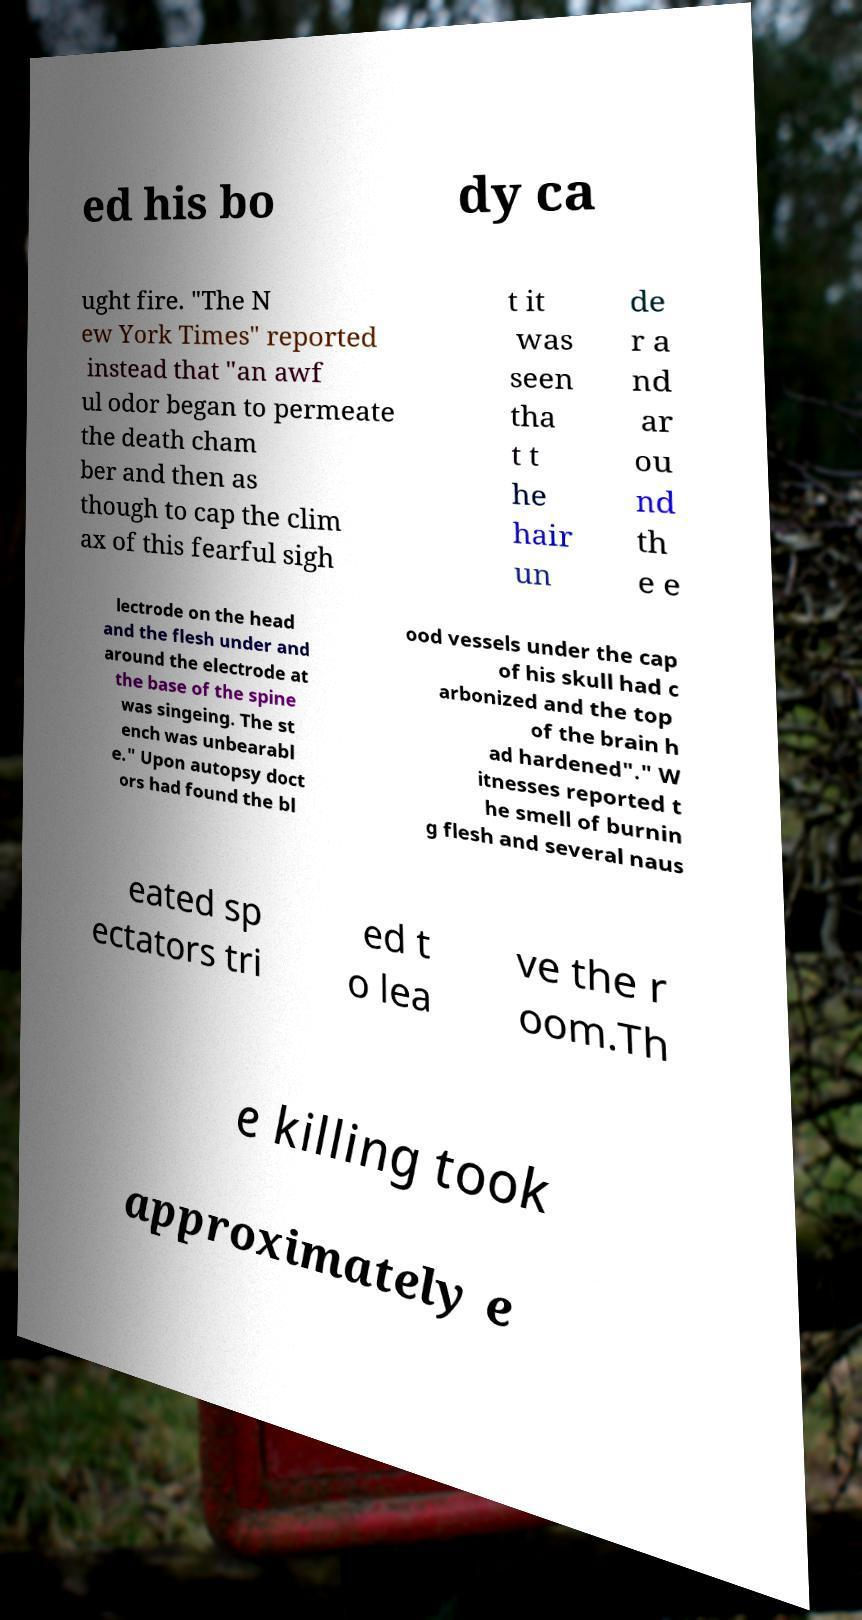For documentation purposes, I need the text within this image transcribed. Could you provide that? ed his bo dy ca ught fire. "The N ew York Times" reported instead that "an awf ul odor began to permeate the death cham ber and then as though to cap the clim ax of this fearful sigh t it was seen tha t t he hair un de r a nd ar ou nd th e e lectrode on the head and the flesh under and around the electrode at the base of the spine was singeing. The st ench was unbearabl e." Upon autopsy doct ors had found the bl ood vessels under the cap of his skull had c arbonized and the top of the brain h ad hardened"." W itnesses reported t he smell of burnin g flesh and several naus eated sp ectators tri ed t o lea ve the r oom.Th e killing took approximately e 